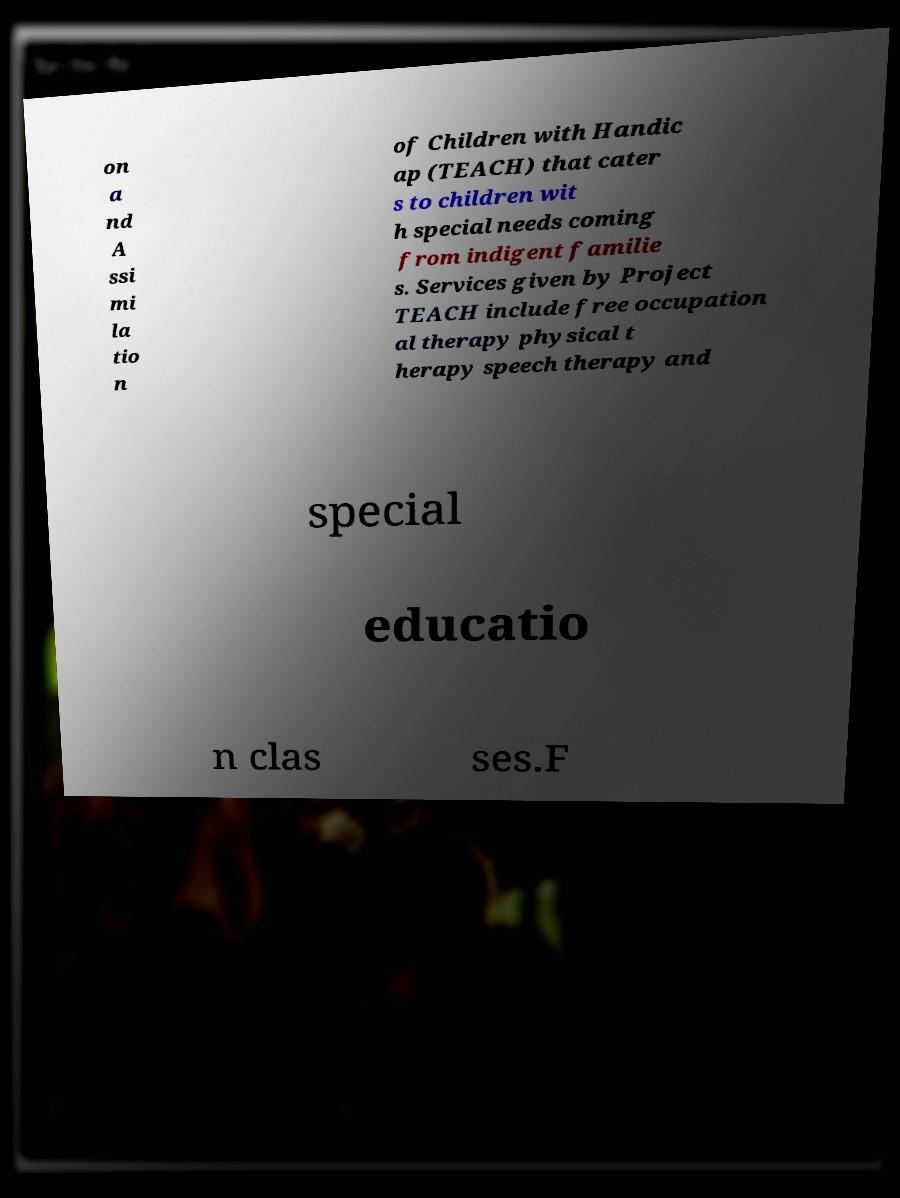For documentation purposes, I need the text within this image transcribed. Could you provide that? on a nd A ssi mi la tio n of Children with Handic ap (TEACH) that cater s to children wit h special needs coming from indigent familie s. Services given by Project TEACH include free occupation al therapy physical t herapy speech therapy and special educatio n clas ses.F 